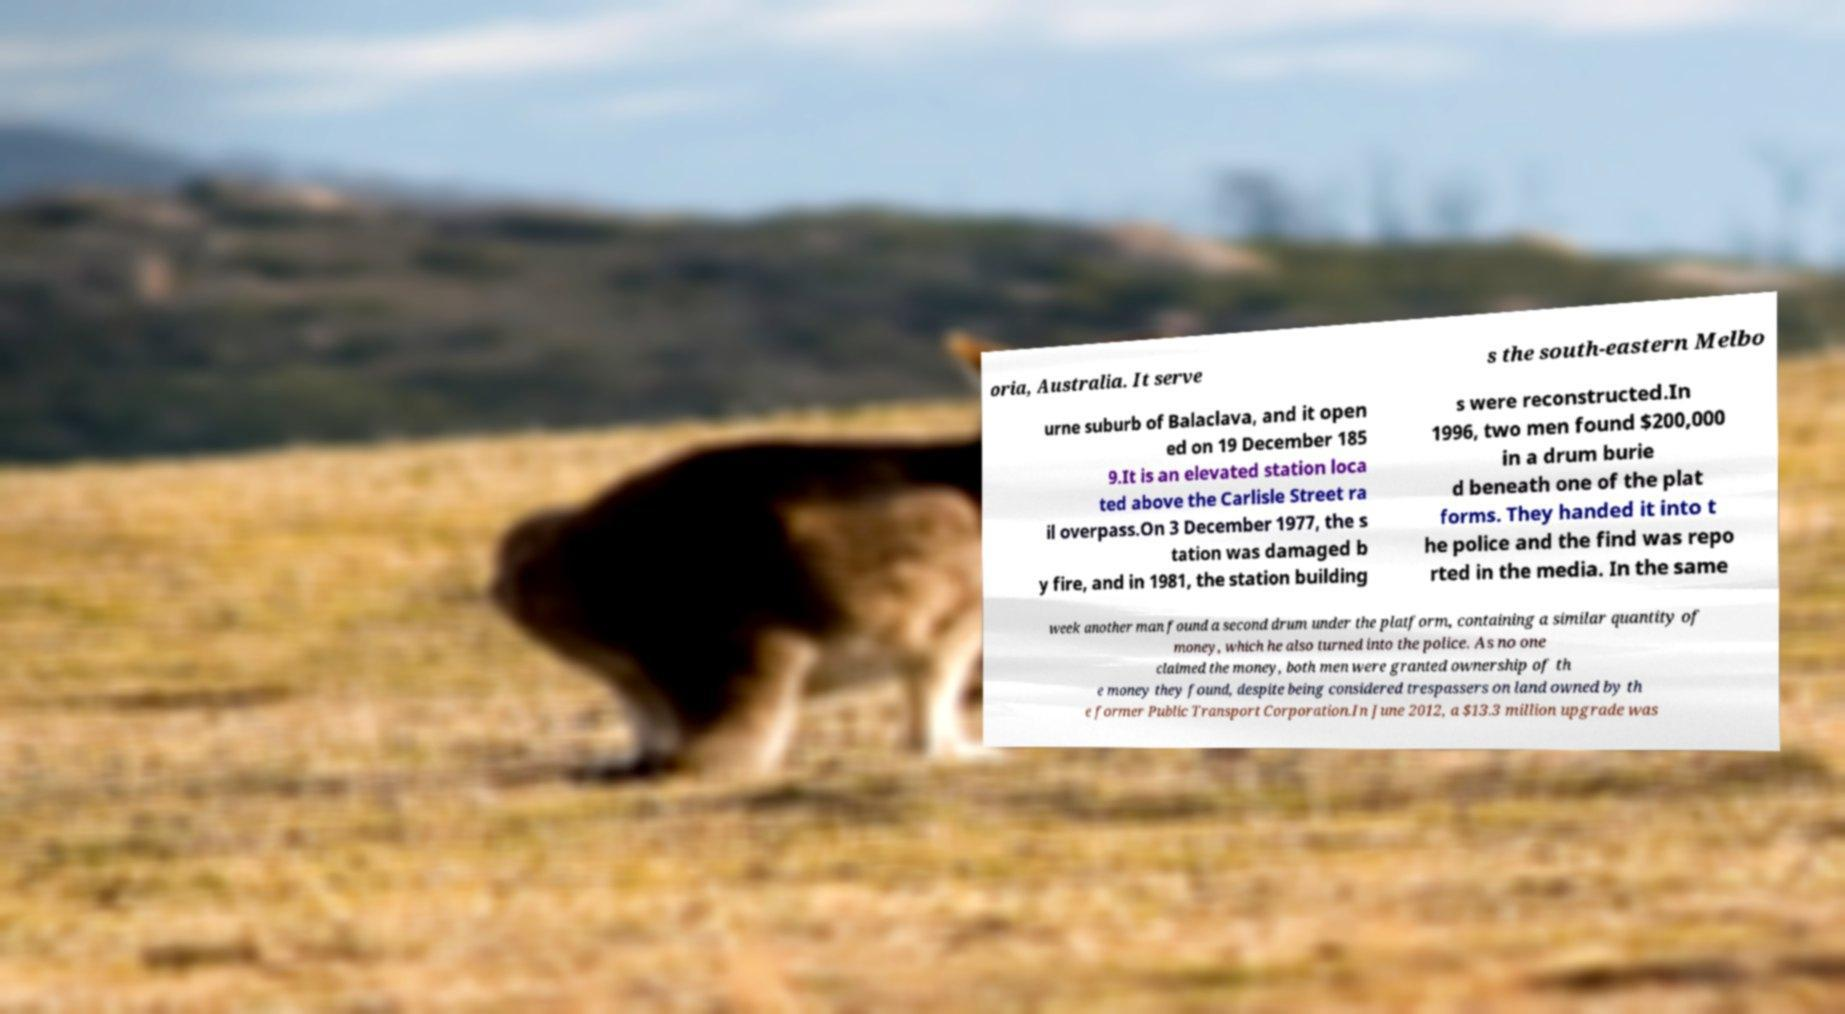Please identify and transcribe the text found in this image. oria, Australia. It serve s the south-eastern Melbo urne suburb of Balaclava, and it open ed on 19 December 185 9.It is an elevated station loca ted above the Carlisle Street ra il overpass.On 3 December 1977, the s tation was damaged b y fire, and in 1981, the station building s were reconstructed.In 1996, two men found $200,000 in a drum burie d beneath one of the plat forms. They handed it into t he police and the find was repo rted in the media. In the same week another man found a second drum under the platform, containing a similar quantity of money, which he also turned into the police. As no one claimed the money, both men were granted ownership of th e money they found, despite being considered trespassers on land owned by th e former Public Transport Corporation.In June 2012, a $13.3 million upgrade was 